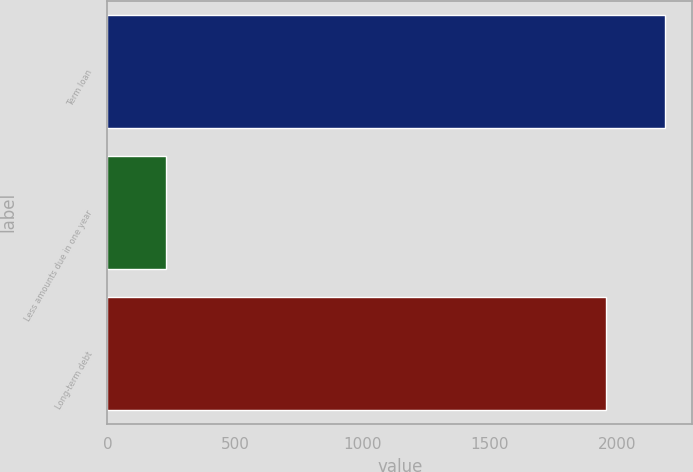Convert chart to OTSL. <chart><loc_0><loc_0><loc_500><loc_500><bar_chart><fcel>Term loan<fcel>Less amounts due in one year<fcel>Long-term debt<nl><fcel>2185<fcel>230<fcel>1955<nl></chart> 